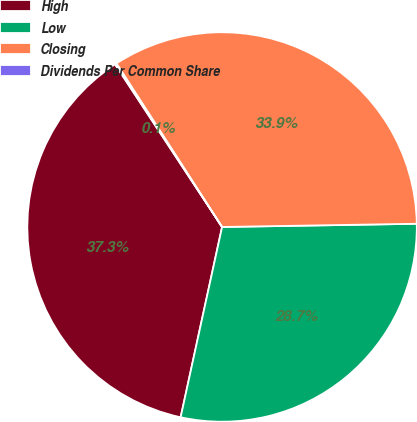<chart> <loc_0><loc_0><loc_500><loc_500><pie_chart><fcel>High<fcel>Low<fcel>Closing<fcel>Dividends Per Common Share<nl><fcel>37.33%<fcel>28.68%<fcel>33.87%<fcel>0.13%<nl></chart> 